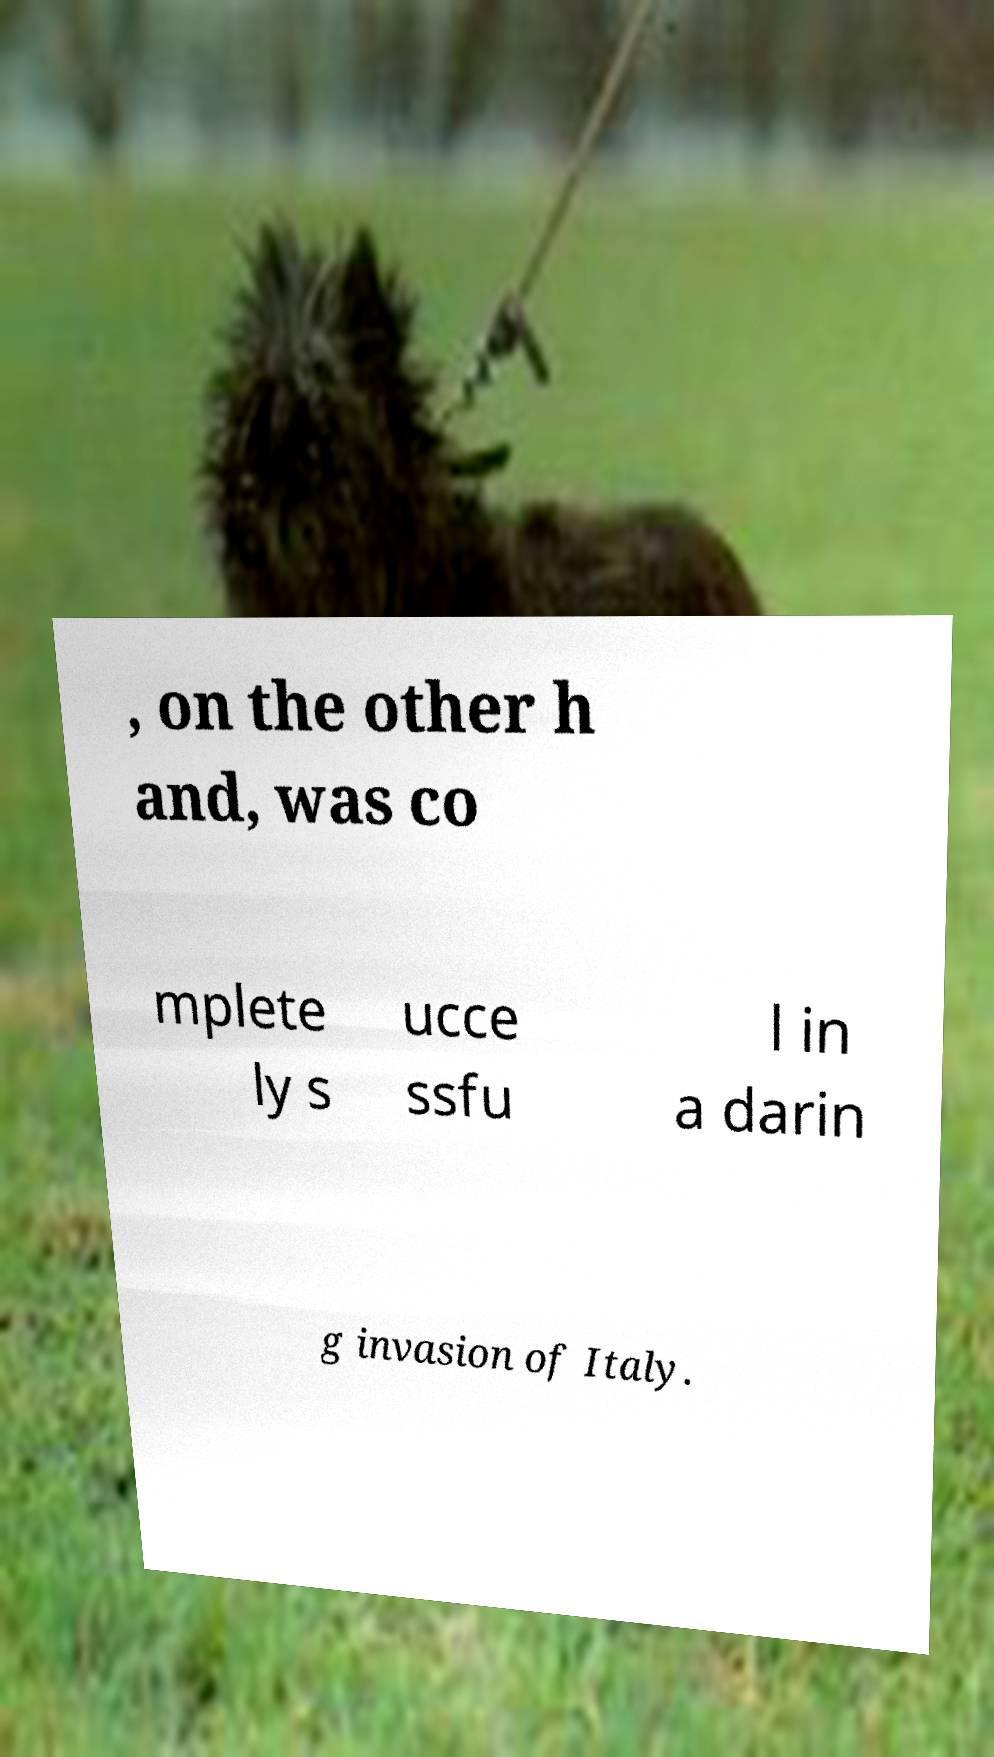For documentation purposes, I need the text within this image transcribed. Could you provide that? , on the other h and, was co mplete ly s ucce ssfu l in a darin g invasion of Italy. 